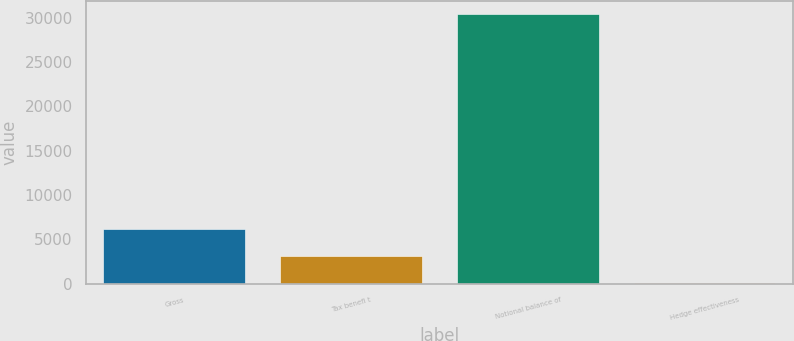Convert chart. <chart><loc_0><loc_0><loc_500><loc_500><bar_chart><fcel>Gross<fcel>Tax benefi t<fcel>Notional balance of<fcel>Hedge effectiveness<nl><fcel>6164<fcel>3132<fcel>30420<fcel>100<nl></chart> 